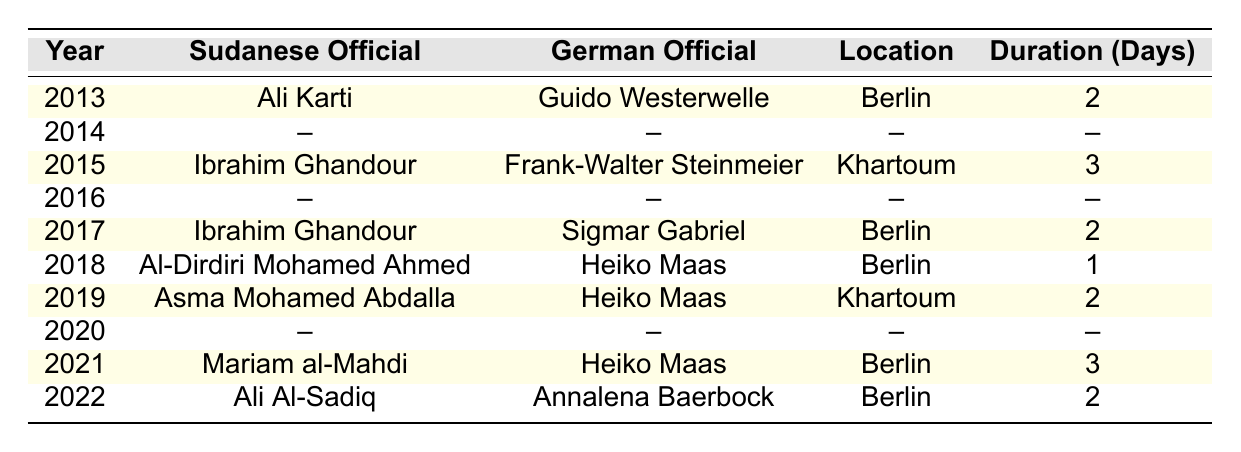What year did Ali Karti visit Germany? The table indicates that Ali Karti visited Germany in 2013.
Answer: 2013 How many days did Ibrahim Ghandour spend during his visit to Germany in 2017? According to the table, Ibrahim Ghandour's visit in 2017 lasted for 2 days.
Answer: 2 days In which location did Asma Mohamed Abdalla meet with Heiko Maas? The table shows that Asma Mohamed Abdalla met with Heiko Maas in Khartoum.
Answer: Khartoum What is the total duration of the diplomatic visits by Sudanese officials in 2021 and 2022? In 2021, the duration was 3 days and in 2022 it was 2 days. Adding these gives 3 + 2 = 5 days total.
Answer: 5 days Was there a diplomatic visit between Sudan and Germany in 2014? The table indicates that there were no visits recorded for the year 2014.
Answer: No Which German official had the most visits to Sudan in the given years? Heiko Maas visited Sudan on two occasions (in 2018 and 2019), more than any other German official in the table.
Answer: Heiko Maas What is the duration of the shortest diplomatic visit listed in the table? The shortest visit recorded in the table is for Al-Dirdiri Mohamed Ahmed in 2018, which lasted 1 day.
Answer: 1 day How many different Sudanese officials visited Germany in the past decade? The table lists 5 unique Sudanese officials who visited Germany: Ali Karti, Ibrahim Ghandour (twice), Al-Dirdiri Mohamed Ahmed, Mariam al-Mahdi, and Ali Al-Sadiq, totaling 5 distinct names.
Answer: 5 officials In which year did Mariam al-Mahdi visit Germany and for how many days? Mariam al-Mahdi visited Germany in 2021 for 3 days, as shown in the table.
Answer: 2021, 3 days What is the average duration of visits by Sudanese officials to Germany based on the recorded visits? The total duration of the recorded visits is 2 + 3 + 2 + 1 + 2 + 3 + 2 = 15 days. There are 7 visits, so the average is 15/7 ≈ 2.14 days.
Answer: Approximately 2.14 days 